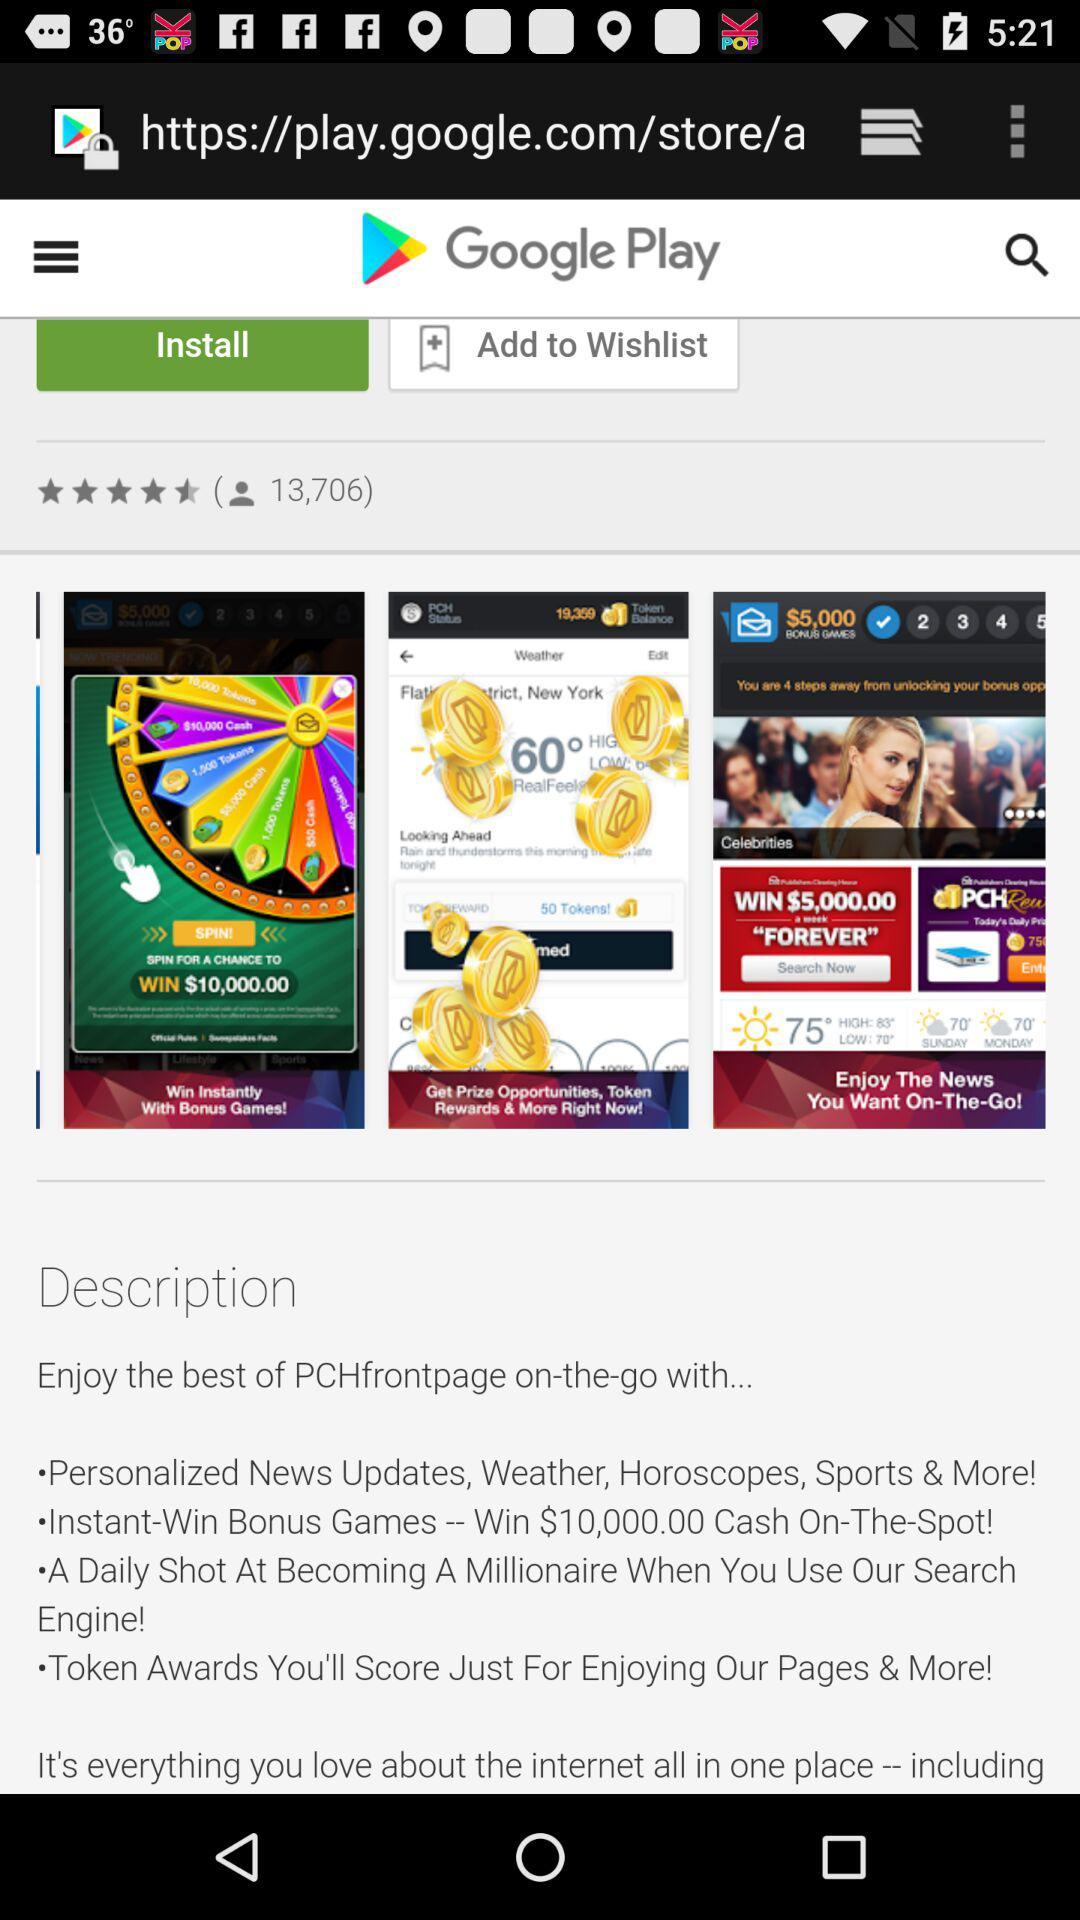What is the rating of the application? The rating of the application is 4.5 stars. 